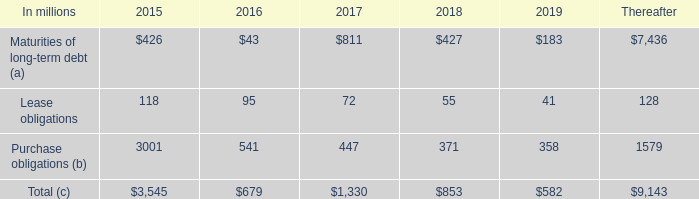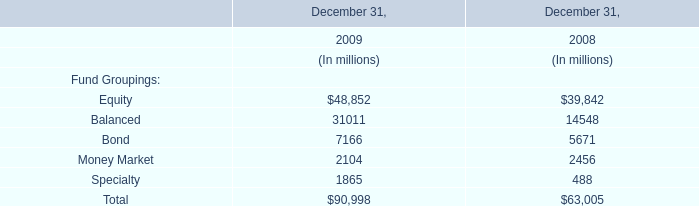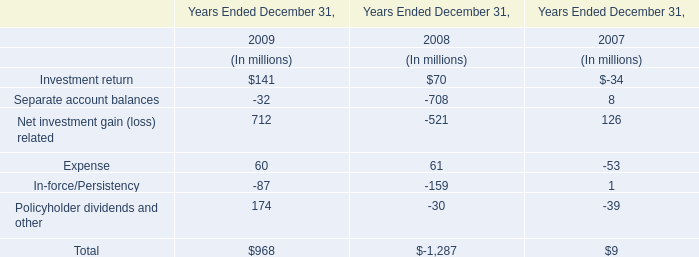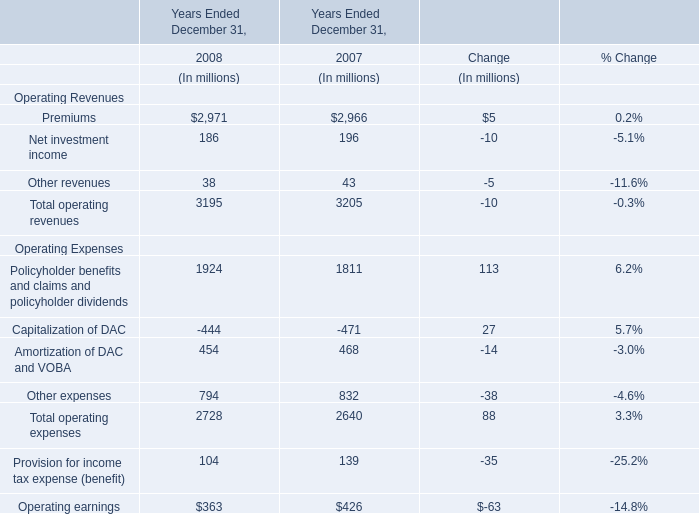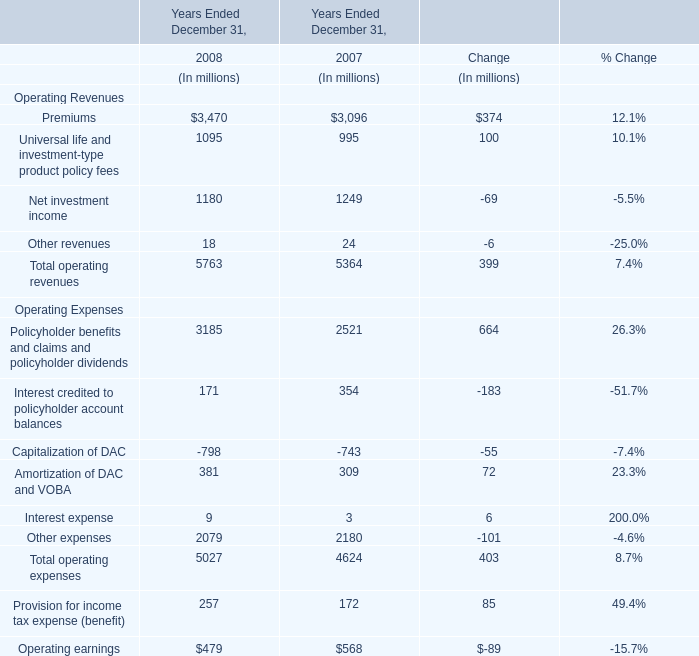What was the total amount of elements in 2008? (in million) 
Computations: (((3195 + 2728) + 104) + 363)
Answer: 6390.0. 